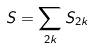Convert formula to latex. <formula><loc_0><loc_0><loc_500><loc_500>S = \sum _ { 2 k } S _ { 2 k }</formula> 